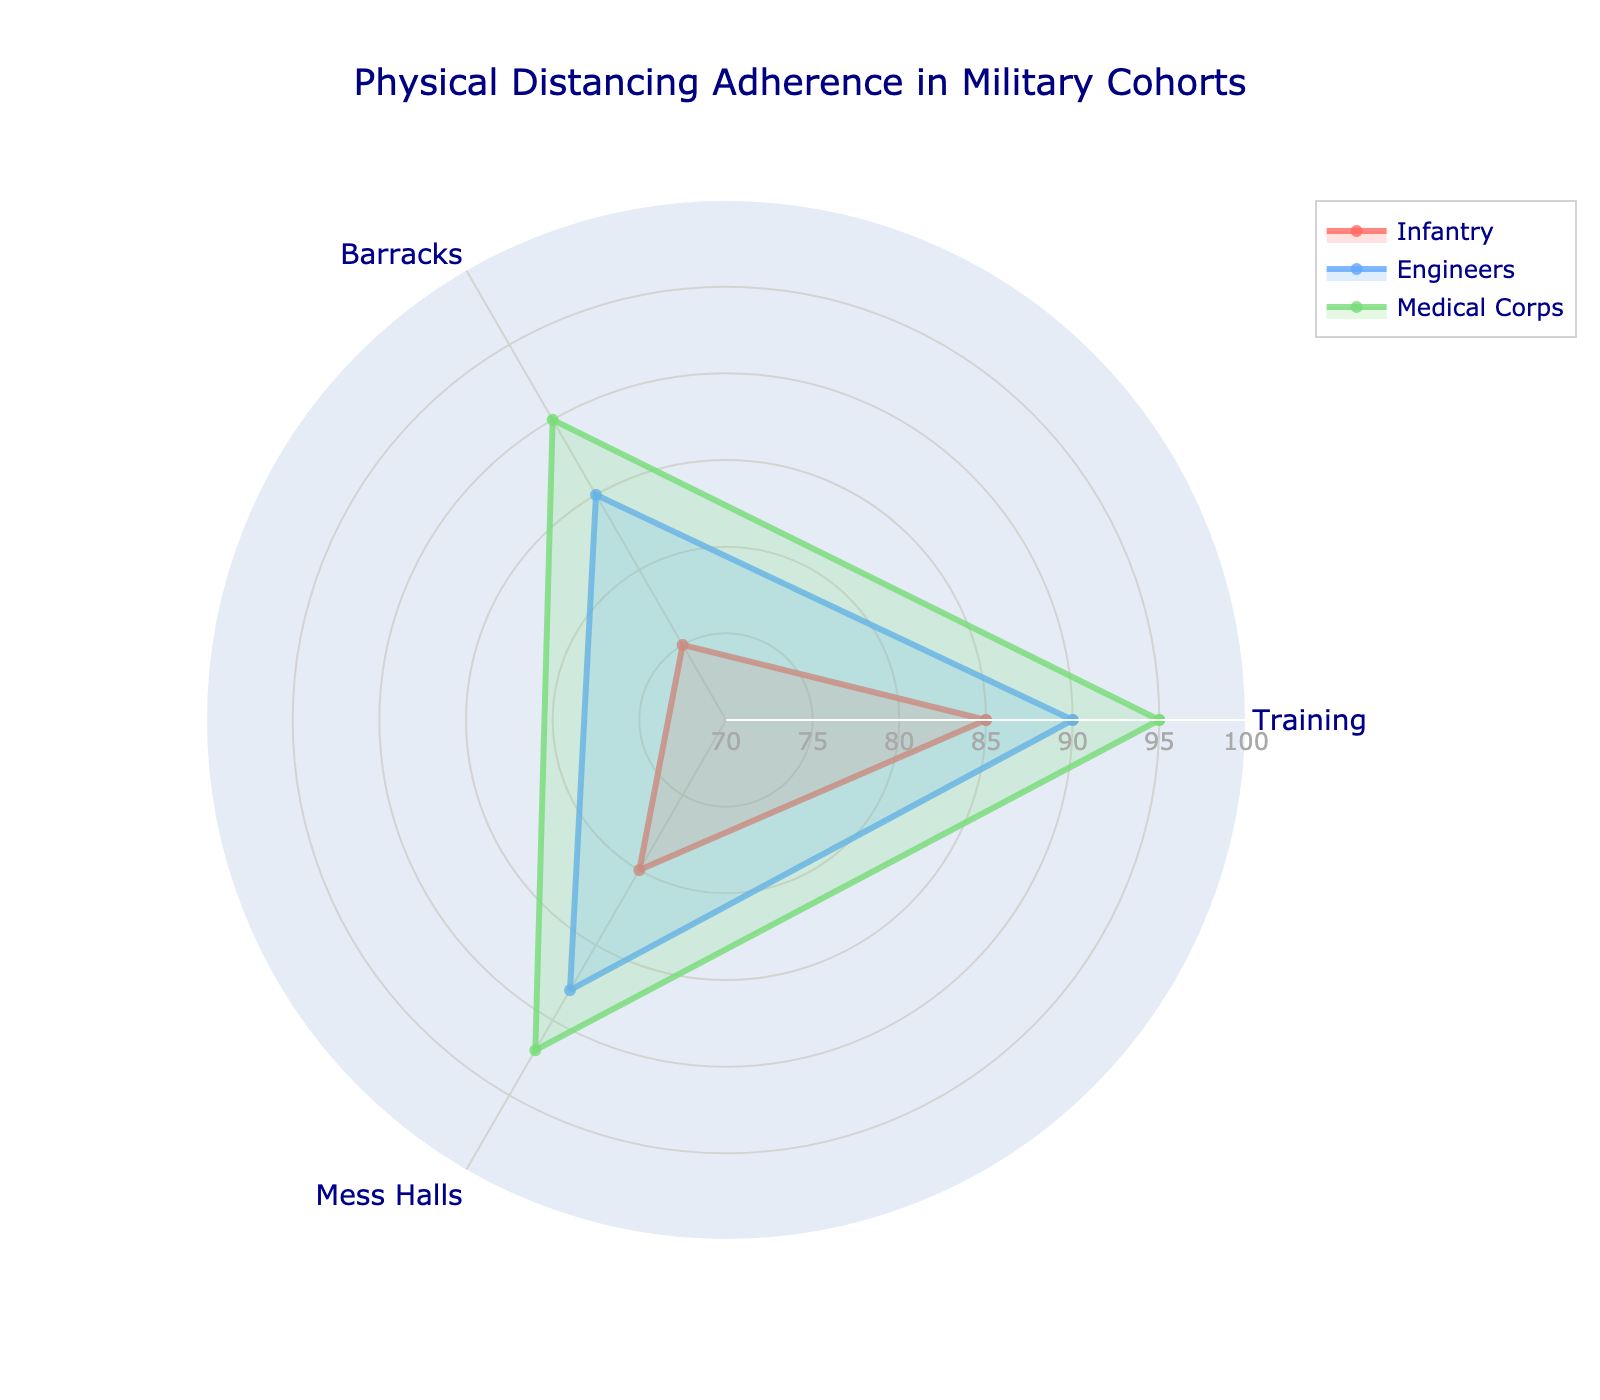What's the title of the radar chart? The title is located at the top of the chart. It summarizes the subject of the chart.
Answer: Physical Distancing Adherence in Military Cohorts What are the categories represented around the radar chart? The categories are the distinct areas where adherence is measured. These are labeled around the chart's perimeter.
Answer: Training, Barracks, Mess Halls Which group shows the highest adherence in the Training category? By observing the values for the Training category, one can see which plot point reaches the highest on the corresponding axis.
Answer: Medical Corps What is the average adherence of the Engineers across all categories? Calculate the average by summing adherence values for Engineers (90+85+88) and dividing by the number of categories (3).
Answer: 87.67 Which category shows the least variation in adherence among all the groups? Variation can be determined by calculating the range (difference between maximum and minimum values) for each category. The category with the smallest range shows the least variation.
Answer: Training (range = 10) Compare the adherence in Barracks between Infantry and Engineers. Which is higher? Look at the Barracks values for Infantry and Engineers. The higher value indicates the greater adherence.
Answer: Engineers (85 vs. 75) What is the sum of adherence values for Medical Corps in all categories? Add the adherence values of the Medical Corps group in Training, Barracks, and Mess Halls categories (95+90+92).
Answer: 277 Which military cohort has the most uniform adherence across all categories? Uniformity can be evaluated by observing the consistency of adherence values across categories for each group. The group with values that are closer together across all categories is the most uniform.
Answer: Medical Corps In which category does the Infantry group have its highest adherence? Observe the adherence values of the Infantry group across all categories. The highest value indicates their best adherence category.
Answer: Training What is the difference in adherence in Mess Halls between Medical Corps and Infantry? Subtract Infantry’s adherence in Mess Halls from Medical Corps’ adherence in Mess Halls (92 - 80).
Answer: 12 